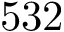Convert formula to latex. <formula><loc_0><loc_0><loc_500><loc_500>5 3 2</formula> 